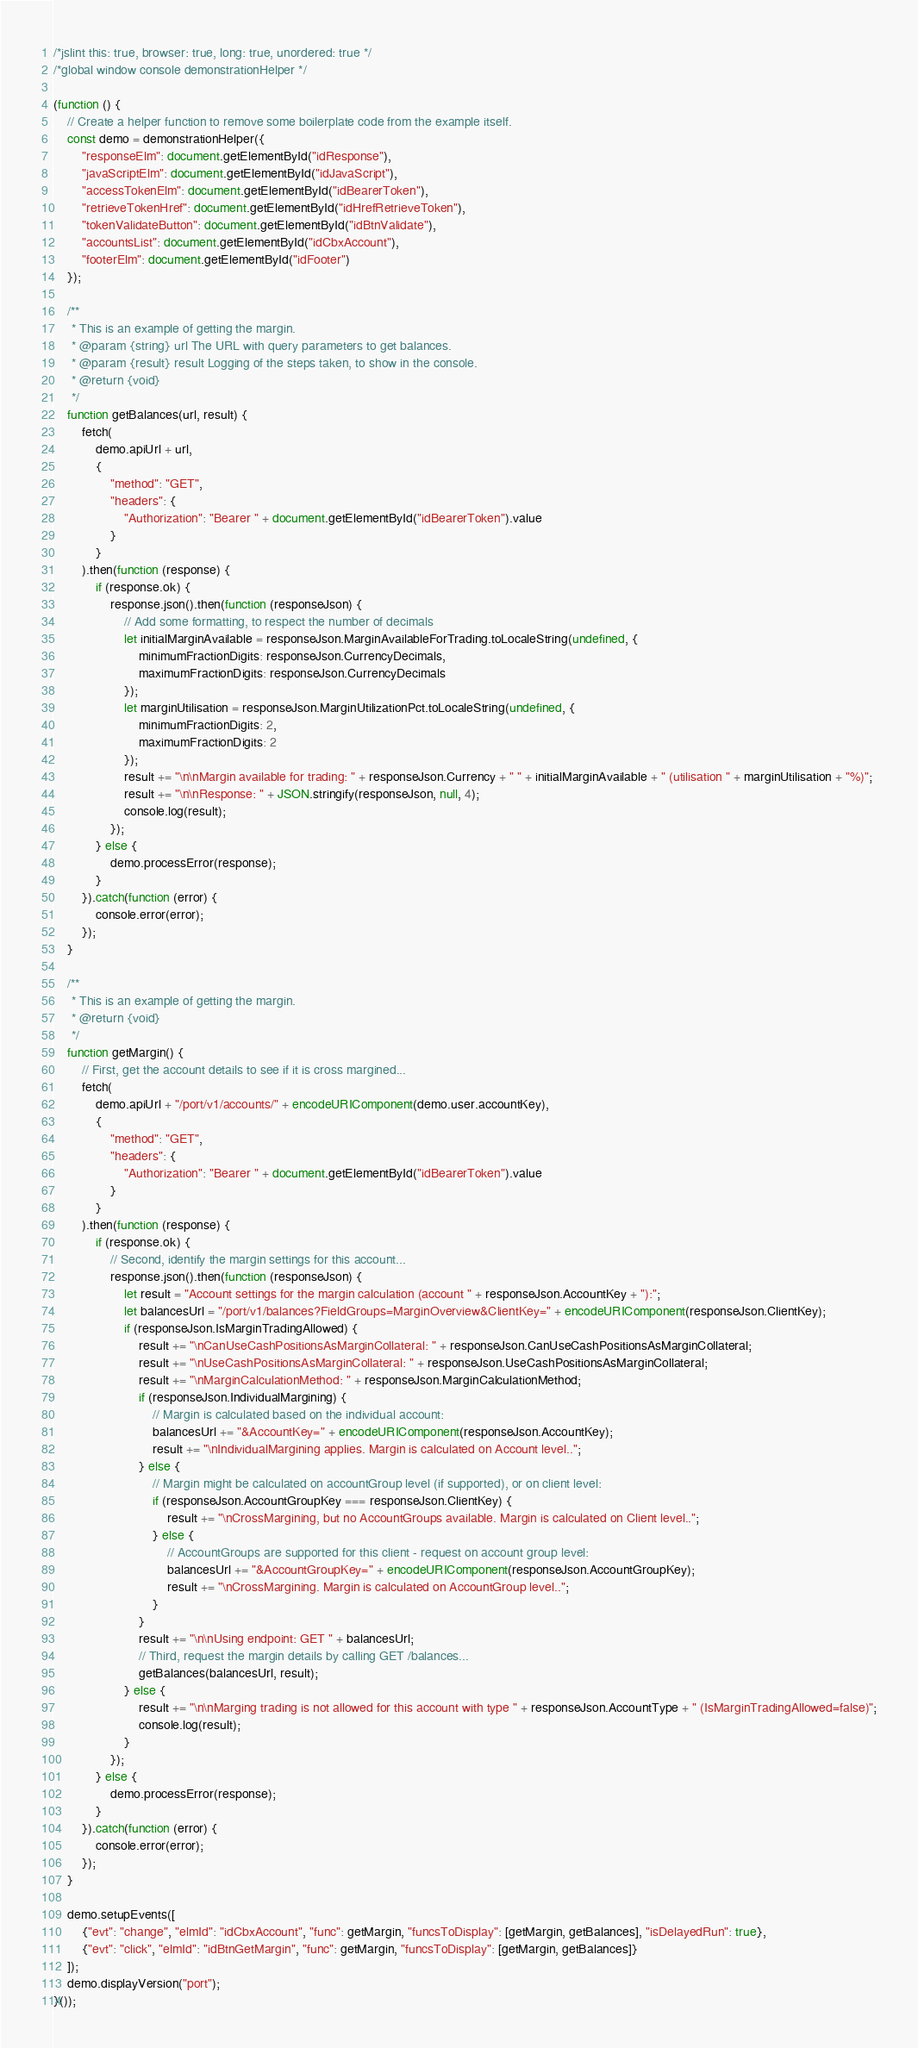Convert code to text. <code><loc_0><loc_0><loc_500><loc_500><_JavaScript_>/*jslint this: true, browser: true, long: true, unordered: true */
/*global window console demonstrationHelper */

(function () {
    // Create a helper function to remove some boilerplate code from the example itself.
    const demo = demonstrationHelper({
        "responseElm": document.getElementById("idResponse"),
        "javaScriptElm": document.getElementById("idJavaScript"),
        "accessTokenElm": document.getElementById("idBearerToken"),
        "retrieveTokenHref": document.getElementById("idHrefRetrieveToken"),
        "tokenValidateButton": document.getElementById("idBtnValidate"),
        "accountsList": document.getElementById("idCbxAccount"),
        "footerElm": document.getElementById("idFooter")
    });

    /**
     * This is an example of getting the margin.
     * @param {string} url The URL with query parameters to get balances.
     * @param {result} result Logging of the steps taken, to show in the console.
     * @return {void}
     */
    function getBalances(url, result) {
        fetch(
            demo.apiUrl + url,
            {
                "method": "GET",
                "headers": {
                    "Authorization": "Bearer " + document.getElementById("idBearerToken").value
                }
            }
        ).then(function (response) {
            if (response.ok) {
                response.json().then(function (responseJson) {
                    // Add some formatting, to respect the number of decimals
                    let initialMarginAvailable = responseJson.MarginAvailableForTrading.toLocaleString(undefined, {
                        minimumFractionDigits: responseJson.CurrencyDecimals,
                        maximumFractionDigits: responseJson.CurrencyDecimals
                    });
                    let marginUtilisation = responseJson.MarginUtilizationPct.toLocaleString(undefined, {
                        minimumFractionDigits: 2,
                        maximumFractionDigits: 2
                    });
                    result += "\n\nMargin available for trading: " + responseJson.Currency + " " + initialMarginAvailable + " (utilisation " + marginUtilisation + "%)";
                    result += "\n\nResponse: " + JSON.stringify(responseJson, null, 4);
                    console.log(result);
                });
            } else {
                demo.processError(response);
            }
        }).catch(function (error) {
            console.error(error);
        });
    }

    /**
     * This is an example of getting the margin.
     * @return {void}
     */
    function getMargin() {
        // First, get the account details to see if it is cross margined...
        fetch(
            demo.apiUrl + "/port/v1/accounts/" + encodeURIComponent(demo.user.accountKey),
            {
                "method": "GET",
                "headers": {
                    "Authorization": "Bearer " + document.getElementById("idBearerToken").value
                }
            }
        ).then(function (response) {
            if (response.ok) {
                // Second, identify the margin settings for this account...
                response.json().then(function (responseJson) {
                    let result = "Account settings for the margin calculation (account " + responseJson.AccountKey + "):";
                    let balancesUrl = "/port/v1/balances?FieldGroups=MarginOverview&ClientKey=" + encodeURIComponent(responseJson.ClientKey);
                    if (responseJson.IsMarginTradingAllowed) {
                        result += "\nCanUseCashPositionsAsMarginCollateral: " + responseJson.CanUseCashPositionsAsMarginCollateral;
                        result += "\nUseCashPositionsAsMarginCollateral: " + responseJson.UseCashPositionsAsMarginCollateral;
                        result += "\nMarginCalculationMethod: " + responseJson.MarginCalculationMethod;
                        if (responseJson.IndividualMargining) {
                            // Margin is calculated based on the individual account:
                            balancesUrl += "&AccountKey=" + encodeURIComponent(responseJson.AccountKey);
                            result += "\nIndividualMargining applies. Margin is calculated on Account level..";
                        } else {
                            // Margin might be calculated on accountGroup level (if supported), or on client level:
                            if (responseJson.AccountGroupKey === responseJson.ClientKey) {
                                result += "\nCrossMargining, but no AccountGroups available. Margin is calculated on Client level..";
                            } else {
                                // AccountGroups are supported for this client - request on account group level:
                                balancesUrl += "&AccountGroupKey=" + encodeURIComponent(responseJson.AccountGroupKey);
                                result += "\nCrossMargining. Margin is calculated on AccountGroup level..";
                            }
                        }
                        result += "\n\nUsing endpoint: GET " + balancesUrl;
                        // Third, request the margin details by calling GET /balances...
                        getBalances(balancesUrl, result);
                    } else {
                        result += "\n\nMarging trading is not allowed for this account with type " + responseJson.AccountType + " (IsMarginTradingAllowed=false)";
                        console.log(result);
                    }
                });
            } else {
                demo.processError(response);
            }
        }).catch(function (error) {
            console.error(error);
        });
    }

    demo.setupEvents([
        {"evt": "change", "elmId": "idCbxAccount", "func": getMargin, "funcsToDisplay": [getMargin, getBalances], "isDelayedRun": true},
        {"evt": "click", "elmId": "idBtnGetMargin", "func": getMargin, "funcsToDisplay": [getMargin, getBalances]}
    ]);
    demo.displayVersion("port");
}());
</code> 